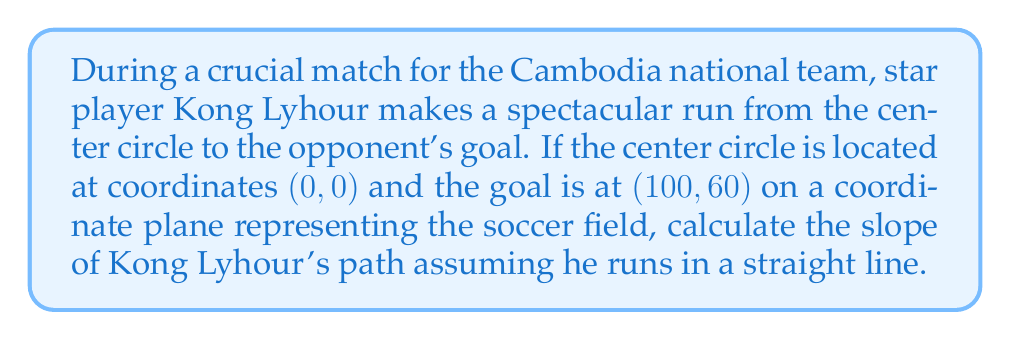Teach me how to tackle this problem. To calculate the slope of Kong Lyhour's path, we'll use the slope formula:

$$ m = \frac{y_2 - y_1}{x_2 - x_1} $$

Where $(x_1, y_1)$ is the starting point and $(x_2, y_2)$ is the ending point.

Given:
- Starting point (center circle): $(x_1, y_1) = (0, 0)$
- Ending point (goal): $(x_2, y_2) = (100, 60)$

Let's plug these values into the slope formula:

$$ m = \frac{60 - 0}{100 - 0} = \frac{60}{100} $$

Simplify the fraction:

$$ m = \frac{3}{5} = 0.6 $$

Therefore, the slope of Kong Lyhour's path is $\frac{3}{5}$ or 0.6.

[asy]
import geometry;

size(200);
draw((0,0)--(100,60), arrow=Arrow(TeXHead));
dot((0,0));
dot((100,60));
label("(0, 0)", (0,0), SW);
label("(100, 60)", (100,60), NE);
label("Kong Lyhour's path", (50,30), NW);
[/asy]
Answer: $\frac{3}{5}$ or 0.6 